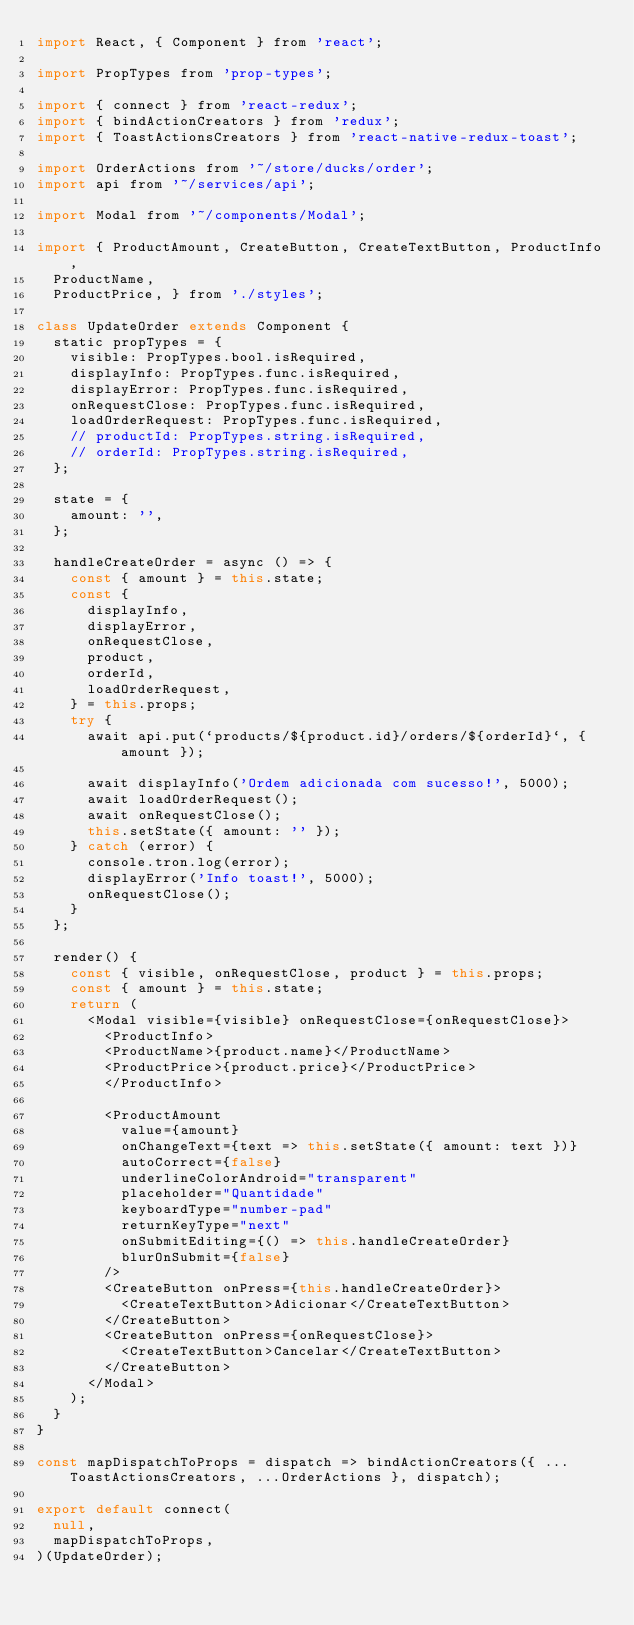<code> <loc_0><loc_0><loc_500><loc_500><_JavaScript_>import React, { Component } from 'react';

import PropTypes from 'prop-types';

import { connect } from 'react-redux';
import { bindActionCreators } from 'redux';
import { ToastActionsCreators } from 'react-native-redux-toast';

import OrderActions from '~/store/ducks/order';
import api from '~/services/api';

import Modal from '~/components/Modal';

import { ProductAmount, CreateButton, CreateTextButton, ProductInfo,
  ProductName,
  ProductPrice, } from './styles';

class UpdateOrder extends Component {
  static propTypes = {
    visible: PropTypes.bool.isRequired,
    displayInfo: PropTypes.func.isRequired,
    displayError: PropTypes.func.isRequired,
    onRequestClose: PropTypes.func.isRequired,
    loadOrderRequest: PropTypes.func.isRequired,
    // productId: PropTypes.string.isRequired,
    // orderId: PropTypes.string.isRequired,
  };

  state = {
    amount: '',
  };

  handleCreateOrder = async () => {
    const { amount } = this.state;
    const {
      displayInfo,
      displayError,
      onRequestClose,
      product,
      orderId,
      loadOrderRequest,
    } = this.props;
    try {
      await api.put(`products/${product.id}/orders/${orderId}`, { amount });

      await displayInfo('Ordem adicionada com sucesso!', 5000);
      await loadOrderRequest();
      await onRequestClose();
      this.setState({ amount: '' });
    } catch (error) {
      console.tron.log(error);
      displayError('Info toast!', 5000);
      onRequestClose();
    }
  };

  render() {
    const { visible, onRequestClose, product } = this.props;
    const { amount } = this.state;
    return (
      <Modal visible={visible} onRequestClose={onRequestClose}>
        <ProductInfo>
        <ProductName>{product.name}</ProductName>
        <ProductPrice>{product.price}</ProductPrice>
        </ProductInfo>
        
        <ProductAmount
          value={amount}
          onChangeText={text => this.setState({ amount: text })}
          autoCorrect={false}
          underlineColorAndroid="transparent"
          placeholder="Quantidade"
          keyboardType="number-pad"
          returnKeyType="next"
          onSubmitEditing={() => this.handleCreateOrder}
          blurOnSubmit={false}
        />
        <CreateButton onPress={this.handleCreateOrder}>
          <CreateTextButton>Adicionar</CreateTextButton>
        </CreateButton>
        <CreateButton onPress={onRequestClose}>
          <CreateTextButton>Cancelar</CreateTextButton>
        </CreateButton>
      </Modal>
    );
  }
}

const mapDispatchToProps = dispatch => bindActionCreators({ ...ToastActionsCreators, ...OrderActions }, dispatch);

export default connect(
  null,
  mapDispatchToProps,
)(UpdateOrder);
</code> 